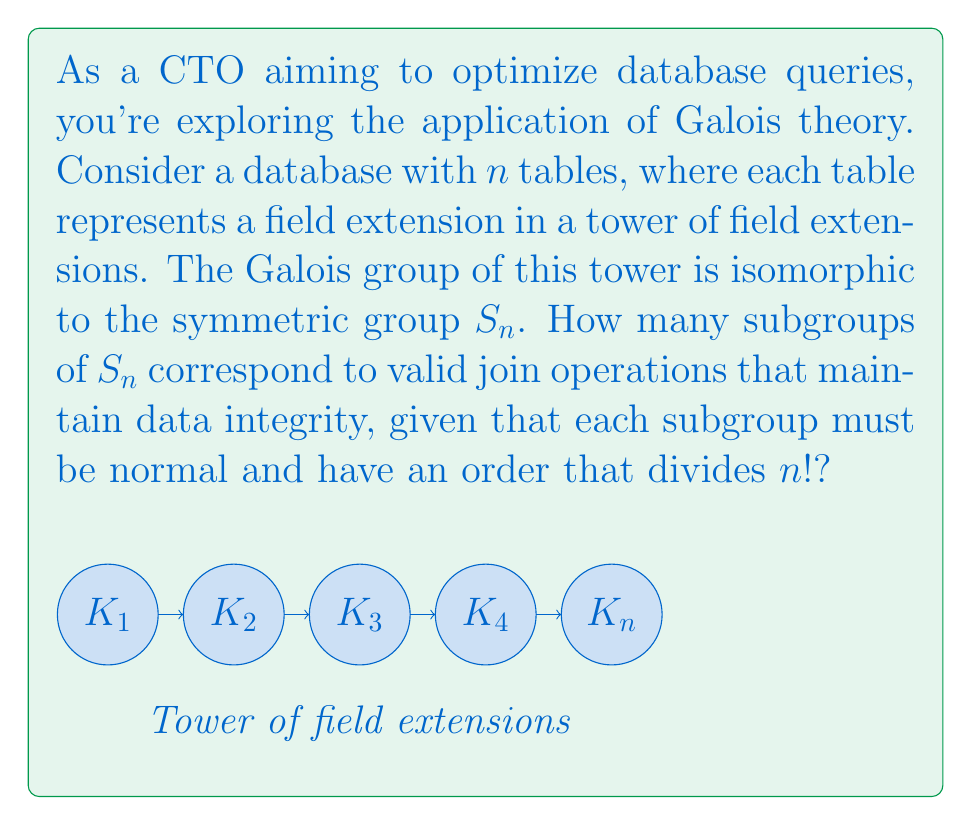What is the answer to this math problem? Let's approach this step-by-step:

1) First, recall that in Galois theory, subfields correspond to subgroups of the Galois group. In our case, valid join operations correspond to normal subgroups of $S_n$.

2) The number of normal subgroups of $S_n$ depends on $n$:

   - For $n < 4$, all subgroups are normal.
   - For $n = 4$, there are 3 normal subgroups: $\{e\}$, $A_4$, and $S_4$.
   - For $n \geq 5$, there are only 2 normal subgroups: $\{e\}$ and $A_n$.

3) However, we also need to consider the condition that the order of the subgroup must divide $n!$. This is always true for $\{e\}$ and $S_n$.

4) For $A_n$, its order is $\frac{n!}{2}$, which divides $n!$ for all $n$.

5) Therefore, the number of valid subgroups is:

   - For $n < 4$: All subgroups of $S_n$ that divide $n!$
   - For $n = 4$: 3 (as all normal subgroups satisfy the order condition)
   - For $n \geq 5$: 2 ($\{e\}$ and $A_n$)

6) As a CTO, you would likely be dealing with databases with many tables, so $n \geq 5$ is the most relevant case.
Answer: 2 (for $n \geq 5$) 